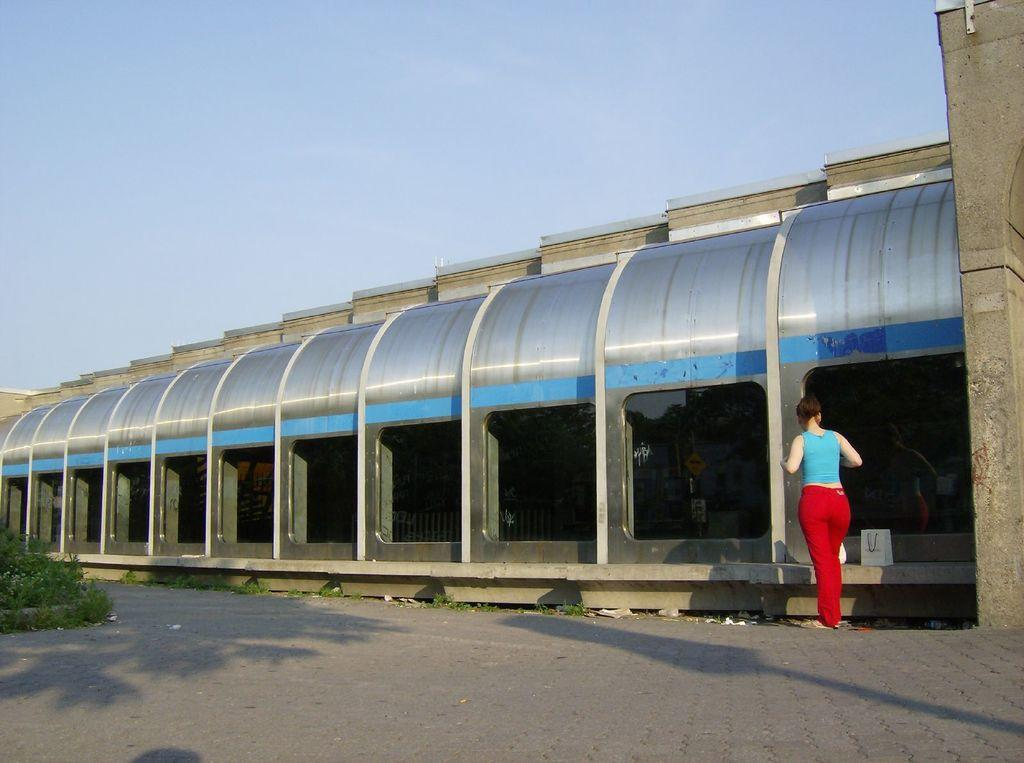What type of structure is present in the image? There is a shed in the image. What colors can be seen on the shed? The shed has blue, ash, and white colors. Can you describe the person in the image? The person is standing in the image and is wearing a blue top and red pants. What type of vegetation is visible in the image? There is green grass visible in the image. What color is the sky in the image? The sky is blue in the image. What type of leather material is being used to milk the cow in the image? There is no cow or leather material present in the image; it features a shed, a person, green grass, and a blue sky. 